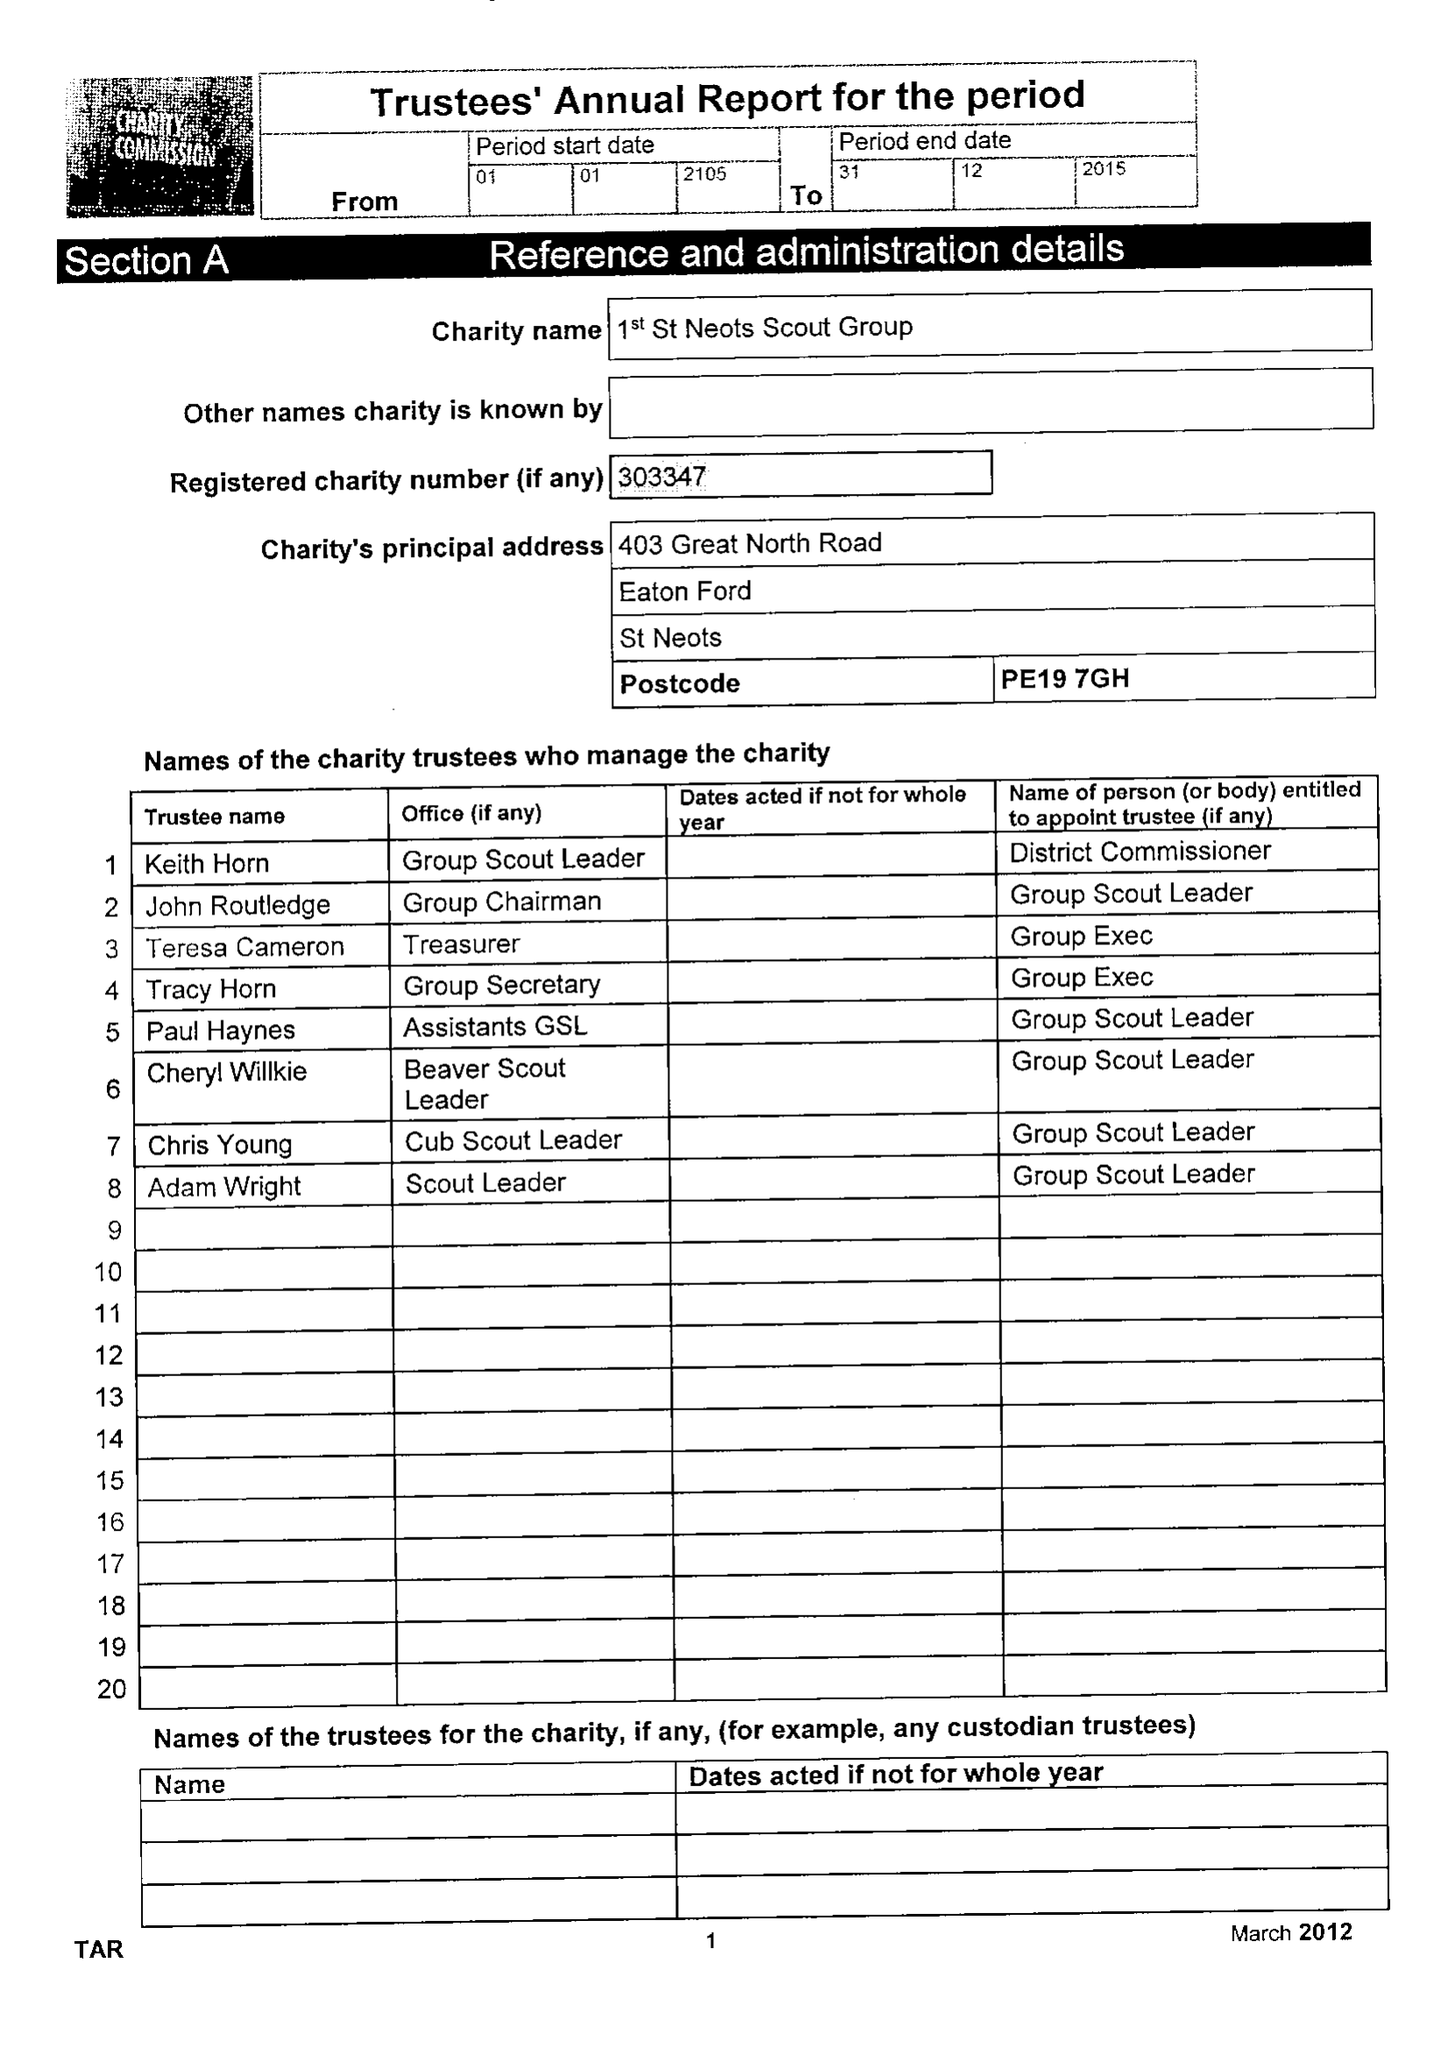What is the value for the report_date?
Answer the question using a single word or phrase. 2015-12-31 